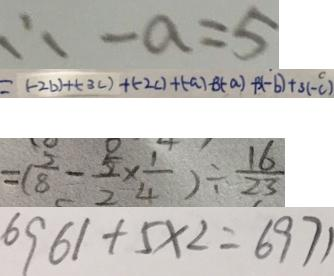<formula> <loc_0><loc_0><loc_500><loc_500>\therefore - a = 5 
 = ( - 2 b ) + ( - 3 c ) + ( - 2 c ) + ( - a ) + 3 ( - a ) + 3 ( - b ) + 3 ( - c ) 
 = ( \frac { 5 } { 8 } - \frac { 5 } { 2 } \times \frac { 1 } { 4 } ) \div \frac { 1 6 } { 2 3 } 
 6 9 6 1 + 5 \times 2 = 6 9 7 1</formula> 